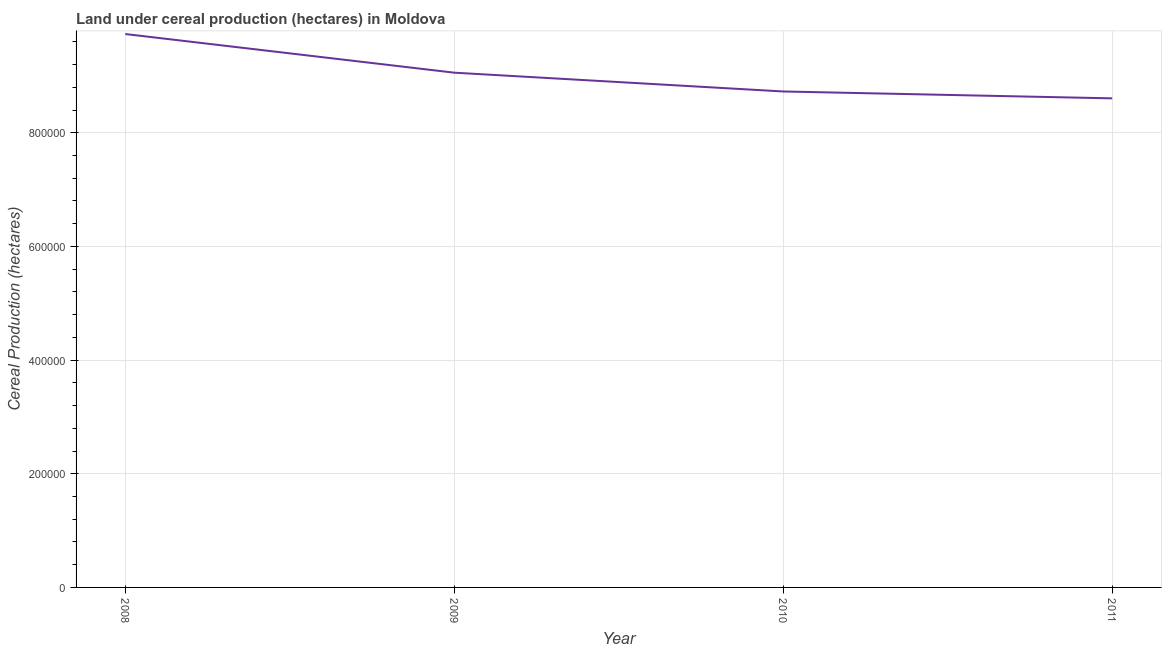What is the land under cereal production in 2008?
Your answer should be compact. 9.74e+05. Across all years, what is the maximum land under cereal production?
Provide a short and direct response. 9.74e+05. Across all years, what is the minimum land under cereal production?
Make the answer very short. 8.61e+05. In which year was the land under cereal production maximum?
Your response must be concise. 2008. What is the sum of the land under cereal production?
Keep it short and to the point. 3.61e+06. What is the difference between the land under cereal production in 2008 and 2010?
Your answer should be very brief. 1.01e+05. What is the average land under cereal production per year?
Your response must be concise. 9.03e+05. What is the median land under cereal production?
Your answer should be very brief. 8.89e+05. Do a majority of the years between 2010 and 2009 (inclusive) have land under cereal production greater than 160000 hectares?
Your answer should be compact. No. What is the ratio of the land under cereal production in 2008 to that in 2009?
Ensure brevity in your answer.  1.08. Is the difference between the land under cereal production in 2009 and 2010 greater than the difference between any two years?
Offer a very short reply. No. What is the difference between the highest and the second highest land under cereal production?
Your answer should be very brief. 6.80e+04. Is the sum of the land under cereal production in 2010 and 2011 greater than the maximum land under cereal production across all years?
Your response must be concise. Yes. What is the difference between the highest and the lowest land under cereal production?
Your answer should be compact. 1.13e+05. Are the values on the major ticks of Y-axis written in scientific E-notation?
Your answer should be very brief. No. Does the graph contain grids?
Your response must be concise. Yes. What is the title of the graph?
Your response must be concise. Land under cereal production (hectares) in Moldova. What is the label or title of the X-axis?
Provide a short and direct response. Year. What is the label or title of the Y-axis?
Offer a very short reply. Cereal Production (hectares). What is the Cereal Production (hectares) in 2008?
Offer a very short reply. 9.74e+05. What is the Cereal Production (hectares) in 2009?
Keep it short and to the point. 9.06e+05. What is the Cereal Production (hectares) of 2010?
Offer a terse response. 8.73e+05. What is the Cereal Production (hectares) in 2011?
Your response must be concise. 8.61e+05. What is the difference between the Cereal Production (hectares) in 2008 and 2009?
Ensure brevity in your answer.  6.80e+04. What is the difference between the Cereal Production (hectares) in 2008 and 2010?
Make the answer very short. 1.01e+05. What is the difference between the Cereal Production (hectares) in 2008 and 2011?
Provide a short and direct response. 1.13e+05. What is the difference between the Cereal Production (hectares) in 2009 and 2010?
Make the answer very short. 3.31e+04. What is the difference between the Cereal Production (hectares) in 2009 and 2011?
Ensure brevity in your answer.  4.52e+04. What is the difference between the Cereal Production (hectares) in 2010 and 2011?
Give a very brief answer. 1.21e+04. What is the ratio of the Cereal Production (hectares) in 2008 to that in 2009?
Offer a very short reply. 1.07. What is the ratio of the Cereal Production (hectares) in 2008 to that in 2010?
Ensure brevity in your answer.  1.12. What is the ratio of the Cereal Production (hectares) in 2008 to that in 2011?
Ensure brevity in your answer.  1.13. What is the ratio of the Cereal Production (hectares) in 2009 to that in 2010?
Offer a terse response. 1.04. What is the ratio of the Cereal Production (hectares) in 2009 to that in 2011?
Provide a short and direct response. 1.05. What is the ratio of the Cereal Production (hectares) in 2010 to that in 2011?
Keep it short and to the point. 1.01. 